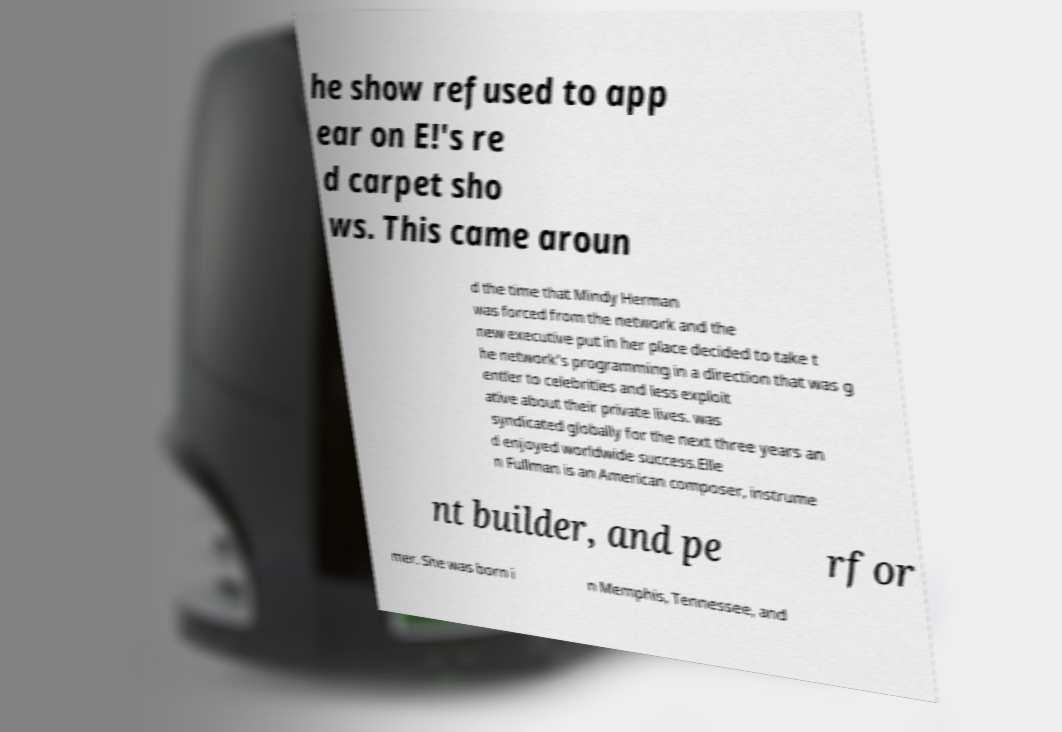There's text embedded in this image that I need extracted. Can you transcribe it verbatim? he show refused to app ear on E!'s re d carpet sho ws. This came aroun d the time that Mindy Herman was forced from the network and the new executive put in her place decided to take t he network's programming in a direction that was g entler to celebrities and less exploit ative about their private lives. was syndicated globally for the next three years an d enjoyed worldwide success.Elle n Fullman is an American composer, instrume nt builder, and pe rfor mer. She was born i n Memphis, Tennessee, and 